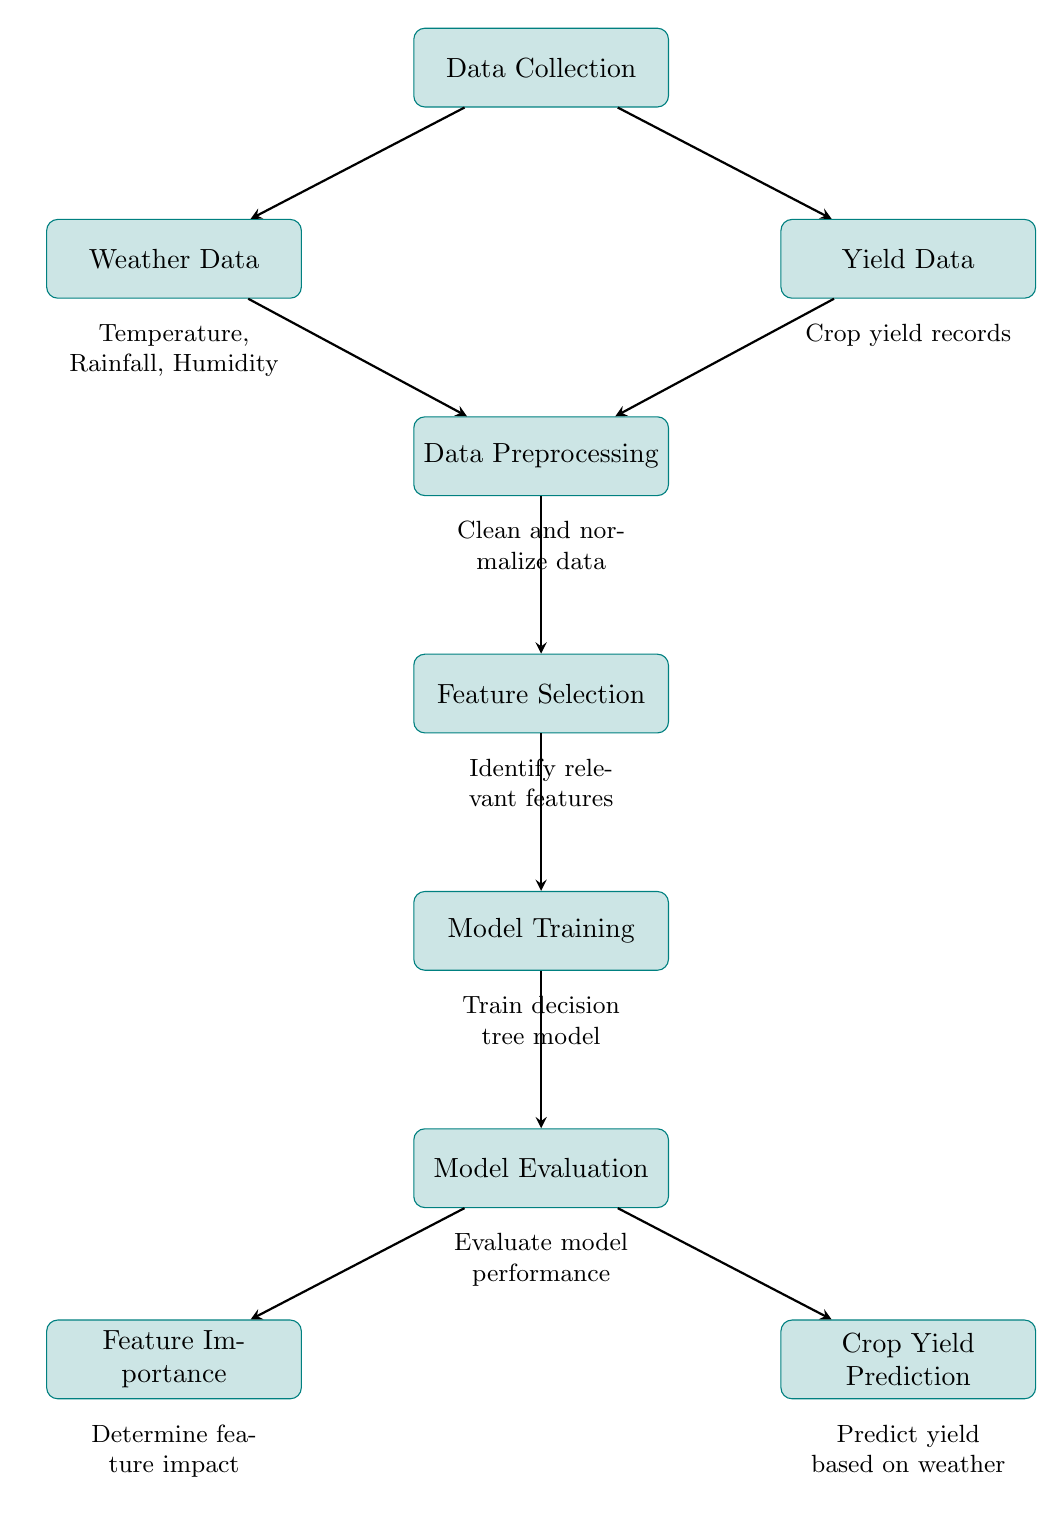What are the three weather factors mentioned in the diagram? The diagram lists "Temperature," "Rainfall," and "Humidity" below the Weather Data node, indicating these are the relevant weather factors considered in predicting crop yield.
Answer: Temperature, Rainfall, Humidity How many main processes are shown in the diagram? The diagram contains eight main processes, which are visually represented as rectangular nodes. These processes are arranged in a vertical flow from data collection to prediction.
Answer: Eight Which process directly follows Data Preprocessing? The process that follows Data Preprocessing is Feature Selection, indicating that after data has been cleansed and organized, the next step is to identify the most relevant features to use for the model.
Answer: Feature Selection What is the output of the Model Evaluation process? The output of the Model Evaluation process leads to two distinct nodes: Feature Importance and Crop Yield Prediction. This indicates that the evaluation informs both the importance of features and the final prediction of crop yield.
Answer: Feature Importance and Crop Yield Prediction Describe the relationship between Weather Data and Yield Data in the diagram. Weather Data and Yield Data are both inputs into the Data Preprocessing node, signifying that the model utilizes both types of data to prepare for further analysis and prediction of crop yield.
Answer: Inputs to Data Preprocessing What is the final outcome of the diagram? The final outcome of the diagram is Crop Yield Prediction, which represents the result of all preceding processes aimed at determining the expected yield from the given weather conditions.
Answer: Crop Yield Prediction Which process involves determining the impact of features? The process that determines feature impact is Feature Importance, which occurs after the model has been evaluated, indicating its role in understanding how different variables affect crop yield.
Answer: Feature Importance Identify the process that includes cleaning and normalizing data. The Data Preprocessing process includes cleaning and normalizing data, ensuring that the information used for modeling is accurate and formatted correctly for analysis.
Answer: Data Preprocessing 